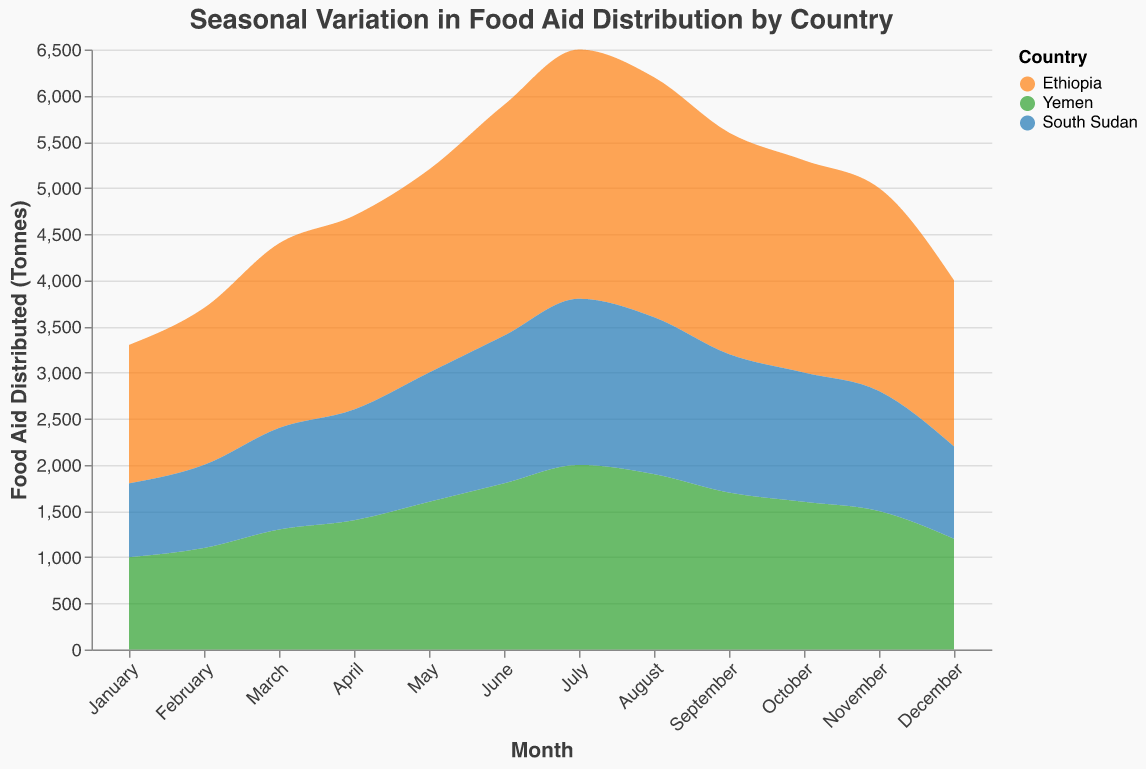What is the title of the area chart? The title of the area chart is at the top of the figure and it reads "Seasonal Variation in Food Aid Distribution by Country."
Answer: Seasonal Variation in Food Aid Distribution by Country During which month does Ethiopia receive the highest amount of food aid? By looking at the data for Ethiopia, the highest amount of food aid distribution occurs in July, with 2700 tonnes.
Answer: July Compare the food aid distributed to Yemen in March and June. Which month received more aid and by how much? Yemen received 1300 tonnes in March and 1800 tonnes in June. Subtracting these values gives 1800 - 1300 = 500.
Answer: June by 500 tonnes What is the difference in the amount of food aid distributed between Ethiopia and South Sudan in August? Ethiopia received 2600 tonnes in August, while South Sudan received 1700 tonnes. The difference is 2600 - 1700 = 900 tonnes.
Answer: 900 tonnes During which three consecutive months does Yemen receive a steady increase in food aid distribution? Yemen receives a steady increase in food aid distribution from April (1400 tonnes) to June (1800 tonnes), with each month showing an increase.
Answer: April to June Which country received the least amount of food aid in December and what was the amount? South Sudan received the least amount of food aid in December, with 1000 tonnes.
Answer: South Sudan, 1000 tonnes Calculate the average amount of food aid distributed to Ethiopia over the entire year. Add the monthly distributions for Ethiopia and divide by 12. Sum is 25000 tonnes (1500+1700+2000+2100+2200+2500+2700+2600+2400+2300+2200+1800) and the average is 25000 / 12 = 2083.33 tonnes.
Answer: 2083.33 tonnes How does the food aid distribution trend for Ethiopia change from June to December? For Ethiopia, food aid increases from June (2500 tonnes) to July (2700 tonnes) and then starts to decrease gradually from August (2600 tonnes) to December (1800 tonnes).
Answer: Increases then decreases Which country shows the most significant seasonal variation in food aid distribution, and what indicates this? Ethiopia shows the most significant seasonal variation, indicated by the high peak in July (2700 tonnes) followed by a rapid decrease towards December (1800 tonnes).
Answer: Ethiopia 